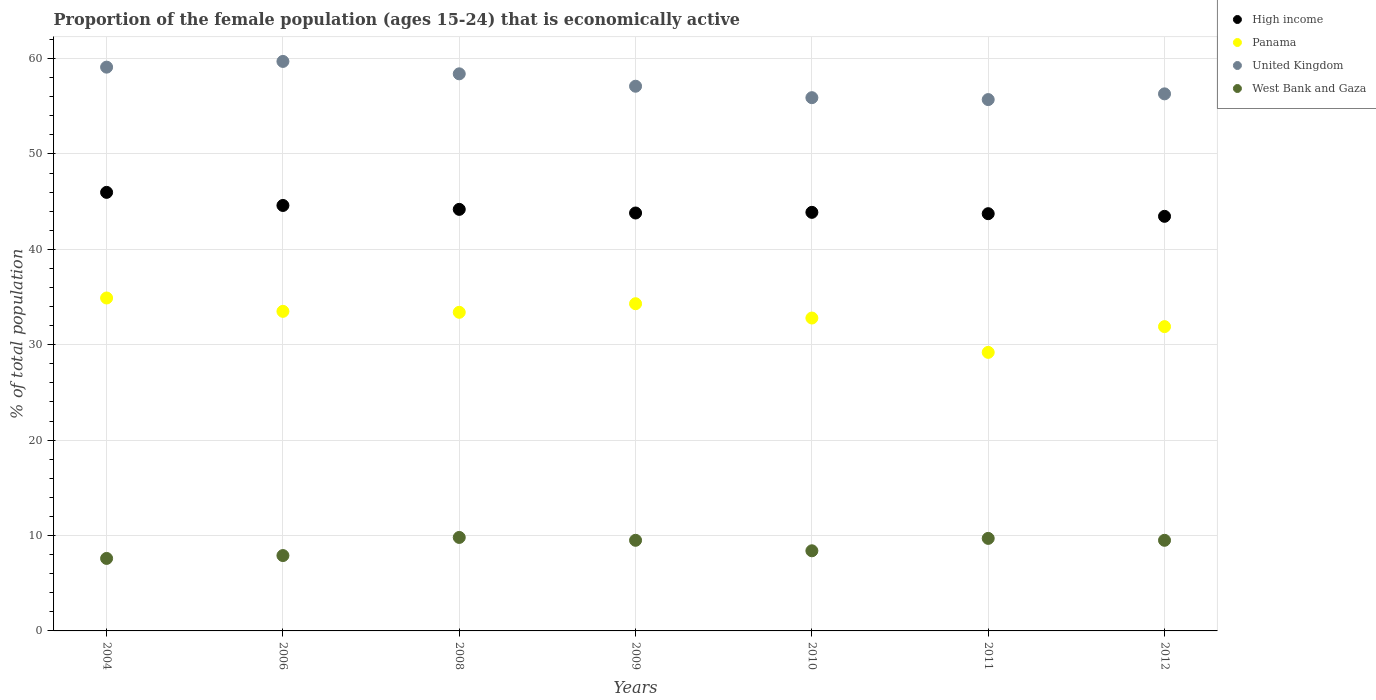Is the number of dotlines equal to the number of legend labels?
Your response must be concise. Yes. What is the proportion of the female population that is economically active in United Kingdom in 2006?
Provide a succinct answer. 59.7. Across all years, what is the maximum proportion of the female population that is economically active in West Bank and Gaza?
Your answer should be very brief. 9.8. Across all years, what is the minimum proportion of the female population that is economically active in Panama?
Make the answer very short. 29.2. In which year was the proportion of the female population that is economically active in Panama maximum?
Offer a very short reply. 2004. In which year was the proportion of the female population that is economically active in West Bank and Gaza minimum?
Make the answer very short. 2004. What is the total proportion of the female population that is economically active in High income in the graph?
Keep it short and to the point. 309.65. What is the difference between the proportion of the female population that is economically active in Panama in 2011 and that in 2012?
Your answer should be very brief. -2.7. What is the difference between the proportion of the female population that is economically active in United Kingdom in 2012 and the proportion of the female population that is economically active in West Bank and Gaza in 2008?
Offer a very short reply. 46.5. What is the average proportion of the female population that is economically active in Panama per year?
Your answer should be very brief. 32.86. In the year 2009, what is the difference between the proportion of the female population that is economically active in Panama and proportion of the female population that is economically active in United Kingdom?
Provide a short and direct response. -22.8. In how many years, is the proportion of the female population that is economically active in United Kingdom greater than 18 %?
Your response must be concise. 7. What is the ratio of the proportion of the female population that is economically active in High income in 2004 to that in 2009?
Provide a short and direct response. 1.05. Is the proportion of the female population that is economically active in West Bank and Gaza in 2006 less than that in 2009?
Provide a succinct answer. Yes. What is the difference between the highest and the second highest proportion of the female population that is economically active in West Bank and Gaza?
Ensure brevity in your answer.  0.1. What is the difference between the highest and the lowest proportion of the female population that is economically active in West Bank and Gaza?
Offer a very short reply. 2.2. In how many years, is the proportion of the female population that is economically active in West Bank and Gaza greater than the average proportion of the female population that is economically active in West Bank and Gaza taken over all years?
Your response must be concise. 4. Is the sum of the proportion of the female population that is economically active in West Bank and Gaza in 2011 and 2012 greater than the maximum proportion of the female population that is economically active in Panama across all years?
Offer a terse response. No. Is it the case that in every year, the sum of the proportion of the female population that is economically active in United Kingdom and proportion of the female population that is economically active in Panama  is greater than the sum of proportion of the female population that is economically active in High income and proportion of the female population that is economically active in West Bank and Gaza?
Provide a succinct answer. No. Is the proportion of the female population that is economically active in West Bank and Gaza strictly greater than the proportion of the female population that is economically active in Panama over the years?
Offer a terse response. No. Is the proportion of the female population that is economically active in High income strictly less than the proportion of the female population that is economically active in West Bank and Gaza over the years?
Make the answer very short. No. How many years are there in the graph?
Your answer should be very brief. 7. Are the values on the major ticks of Y-axis written in scientific E-notation?
Your answer should be very brief. No. Where does the legend appear in the graph?
Keep it short and to the point. Top right. What is the title of the graph?
Keep it short and to the point. Proportion of the female population (ages 15-24) that is economically active. Does "Barbados" appear as one of the legend labels in the graph?
Offer a very short reply. No. What is the label or title of the Y-axis?
Offer a terse response. % of total population. What is the % of total population of High income in 2004?
Give a very brief answer. 45.97. What is the % of total population of Panama in 2004?
Give a very brief answer. 34.9. What is the % of total population in United Kingdom in 2004?
Your answer should be compact. 59.1. What is the % of total population in West Bank and Gaza in 2004?
Your answer should be compact. 7.6. What is the % of total population of High income in 2006?
Offer a very short reply. 44.6. What is the % of total population of Panama in 2006?
Give a very brief answer. 33.5. What is the % of total population in United Kingdom in 2006?
Your answer should be very brief. 59.7. What is the % of total population of West Bank and Gaza in 2006?
Provide a succinct answer. 7.9. What is the % of total population in High income in 2008?
Your response must be concise. 44.19. What is the % of total population of Panama in 2008?
Provide a short and direct response. 33.4. What is the % of total population in United Kingdom in 2008?
Give a very brief answer. 58.4. What is the % of total population of West Bank and Gaza in 2008?
Offer a very short reply. 9.8. What is the % of total population of High income in 2009?
Your answer should be compact. 43.81. What is the % of total population in Panama in 2009?
Ensure brevity in your answer.  34.3. What is the % of total population in United Kingdom in 2009?
Ensure brevity in your answer.  57.1. What is the % of total population of West Bank and Gaza in 2009?
Offer a terse response. 9.5. What is the % of total population of High income in 2010?
Offer a terse response. 43.88. What is the % of total population in Panama in 2010?
Offer a very short reply. 32.8. What is the % of total population of United Kingdom in 2010?
Provide a succinct answer. 55.9. What is the % of total population of West Bank and Gaza in 2010?
Offer a terse response. 8.4. What is the % of total population of High income in 2011?
Your answer should be compact. 43.74. What is the % of total population in Panama in 2011?
Make the answer very short. 29.2. What is the % of total population of United Kingdom in 2011?
Your answer should be compact. 55.7. What is the % of total population in West Bank and Gaza in 2011?
Give a very brief answer. 9.7. What is the % of total population in High income in 2012?
Ensure brevity in your answer.  43.46. What is the % of total population of Panama in 2012?
Give a very brief answer. 31.9. What is the % of total population in United Kingdom in 2012?
Your answer should be very brief. 56.3. Across all years, what is the maximum % of total population of High income?
Your answer should be compact. 45.97. Across all years, what is the maximum % of total population in Panama?
Give a very brief answer. 34.9. Across all years, what is the maximum % of total population of United Kingdom?
Provide a succinct answer. 59.7. Across all years, what is the maximum % of total population of West Bank and Gaza?
Offer a terse response. 9.8. Across all years, what is the minimum % of total population of High income?
Ensure brevity in your answer.  43.46. Across all years, what is the minimum % of total population of Panama?
Your response must be concise. 29.2. Across all years, what is the minimum % of total population of United Kingdom?
Provide a short and direct response. 55.7. Across all years, what is the minimum % of total population of West Bank and Gaza?
Give a very brief answer. 7.6. What is the total % of total population of High income in the graph?
Ensure brevity in your answer.  309.65. What is the total % of total population in Panama in the graph?
Provide a short and direct response. 230. What is the total % of total population of United Kingdom in the graph?
Provide a succinct answer. 402.2. What is the total % of total population of West Bank and Gaza in the graph?
Keep it short and to the point. 62.4. What is the difference between the % of total population in High income in 2004 and that in 2006?
Your answer should be compact. 1.37. What is the difference between the % of total population in West Bank and Gaza in 2004 and that in 2006?
Give a very brief answer. -0.3. What is the difference between the % of total population of High income in 2004 and that in 2008?
Keep it short and to the point. 1.78. What is the difference between the % of total population in United Kingdom in 2004 and that in 2008?
Give a very brief answer. 0.7. What is the difference between the % of total population of High income in 2004 and that in 2009?
Offer a very short reply. 2.16. What is the difference between the % of total population of United Kingdom in 2004 and that in 2009?
Ensure brevity in your answer.  2. What is the difference between the % of total population of High income in 2004 and that in 2010?
Provide a short and direct response. 2.09. What is the difference between the % of total population in United Kingdom in 2004 and that in 2010?
Ensure brevity in your answer.  3.2. What is the difference between the % of total population of High income in 2004 and that in 2011?
Provide a succinct answer. 2.23. What is the difference between the % of total population of Panama in 2004 and that in 2011?
Your answer should be compact. 5.7. What is the difference between the % of total population in West Bank and Gaza in 2004 and that in 2011?
Provide a succinct answer. -2.1. What is the difference between the % of total population in High income in 2004 and that in 2012?
Your response must be concise. 2.51. What is the difference between the % of total population in United Kingdom in 2004 and that in 2012?
Make the answer very short. 2.8. What is the difference between the % of total population in High income in 2006 and that in 2008?
Give a very brief answer. 0.41. What is the difference between the % of total population in United Kingdom in 2006 and that in 2008?
Provide a succinct answer. 1.3. What is the difference between the % of total population of West Bank and Gaza in 2006 and that in 2008?
Provide a short and direct response. -1.9. What is the difference between the % of total population of High income in 2006 and that in 2009?
Ensure brevity in your answer.  0.79. What is the difference between the % of total population of Panama in 2006 and that in 2009?
Keep it short and to the point. -0.8. What is the difference between the % of total population of High income in 2006 and that in 2010?
Provide a succinct answer. 0.72. What is the difference between the % of total population of Panama in 2006 and that in 2010?
Offer a very short reply. 0.7. What is the difference between the % of total population of United Kingdom in 2006 and that in 2010?
Your answer should be compact. 3.8. What is the difference between the % of total population of High income in 2006 and that in 2011?
Keep it short and to the point. 0.86. What is the difference between the % of total population of Panama in 2006 and that in 2011?
Your answer should be compact. 4.3. What is the difference between the % of total population in United Kingdom in 2006 and that in 2011?
Your response must be concise. 4. What is the difference between the % of total population in West Bank and Gaza in 2006 and that in 2011?
Give a very brief answer. -1.8. What is the difference between the % of total population of High income in 2006 and that in 2012?
Offer a terse response. 1.14. What is the difference between the % of total population of High income in 2008 and that in 2009?
Your answer should be compact. 0.38. What is the difference between the % of total population in Panama in 2008 and that in 2009?
Provide a short and direct response. -0.9. What is the difference between the % of total population in United Kingdom in 2008 and that in 2009?
Your answer should be compact. 1.3. What is the difference between the % of total population of High income in 2008 and that in 2010?
Provide a succinct answer. 0.31. What is the difference between the % of total population in High income in 2008 and that in 2011?
Provide a succinct answer. 0.45. What is the difference between the % of total population of West Bank and Gaza in 2008 and that in 2011?
Give a very brief answer. 0.1. What is the difference between the % of total population in High income in 2008 and that in 2012?
Make the answer very short. 0.73. What is the difference between the % of total population of Panama in 2008 and that in 2012?
Provide a short and direct response. 1.5. What is the difference between the % of total population in West Bank and Gaza in 2008 and that in 2012?
Keep it short and to the point. 0.3. What is the difference between the % of total population of High income in 2009 and that in 2010?
Keep it short and to the point. -0.07. What is the difference between the % of total population in Panama in 2009 and that in 2010?
Your answer should be very brief. 1.5. What is the difference between the % of total population of High income in 2009 and that in 2011?
Provide a succinct answer. 0.07. What is the difference between the % of total population in West Bank and Gaza in 2009 and that in 2011?
Your answer should be compact. -0.2. What is the difference between the % of total population of High income in 2009 and that in 2012?
Give a very brief answer. 0.35. What is the difference between the % of total population of United Kingdom in 2009 and that in 2012?
Make the answer very short. 0.8. What is the difference between the % of total population of High income in 2010 and that in 2011?
Provide a short and direct response. 0.14. What is the difference between the % of total population of West Bank and Gaza in 2010 and that in 2011?
Offer a very short reply. -1.3. What is the difference between the % of total population of High income in 2010 and that in 2012?
Offer a very short reply. 0.42. What is the difference between the % of total population in West Bank and Gaza in 2010 and that in 2012?
Make the answer very short. -1.1. What is the difference between the % of total population in High income in 2011 and that in 2012?
Provide a short and direct response. 0.28. What is the difference between the % of total population in High income in 2004 and the % of total population in Panama in 2006?
Provide a succinct answer. 12.47. What is the difference between the % of total population in High income in 2004 and the % of total population in United Kingdom in 2006?
Give a very brief answer. -13.73. What is the difference between the % of total population of High income in 2004 and the % of total population of West Bank and Gaza in 2006?
Offer a very short reply. 38.07. What is the difference between the % of total population in Panama in 2004 and the % of total population in United Kingdom in 2006?
Make the answer very short. -24.8. What is the difference between the % of total population of Panama in 2004 and the % of total population of West Bank and Gaza in 2006?
Your answer should be compact. 27. What is the difference between the % of total population in United Kingdom in 2004 and the % of total population in West Bank and Gaza in 2006?
Give a very brief answer. 51.2. What is the difference between the % of total population in High income in 2004 and the % of total population in Panama in 2008?
Provide a succinct answer. 12.57. What is the difference between the % of total population of High income in 2004 and the % of total population of United Kingdom in 2008?
Give a very brief answer. -12.43. What is the difference between the % of total population of High income in 2004 and the % of total population of West Bank and Gaza in 2008?
Ensure brevity in your answer.  36.17. What is the difference between the % of total population of Panama in 2004 and the % of total population of United Kingdom in 2008?
Offer a terse response. -23.5. What is the difference between the % of total population in Panama in 2004 and the % of total population in West Bank and Gaza in 2008?
Your response must be concise. 25.1. What is the difference between the % of total population in United Kingdom in 2004 and the % of total population in West Bank and Gaza in 2008?
Offer a terse response. 49.3. What is the difference between the % of total population in High income in 2004 and the % of total population in Panama in 2009?
Your answer should be compact. 11.67. What is the difference between the % of total population of High income in 2004 and the % of total population of United Kingdom in 2009?
Offer a very short reply. -11.13. What is the difference between the % of total population in High income in 2004 and the % of total population in West Bank and Gaza in 2009?
Offer a very short reply. 36.47. What is the difference between the % of total population in Panama in 2004 and the % of total population in United Kingdom in 2009?
Keep it short and to the point. -22.2. What is the difference between the % of total population in Panama in 2004 and the % of total population in West Bank and Gaza in 2009?
Keep it short and to the point. 25.4. What is the difference between the % of total population in United Kingdom in 2004 and the % of total population in West Bank and Gaza in 2009?
Provide a short and direct response. 49.6. What is the difference between the % of total population of High income in 2004 and the % of total population of Panama in 2010?
Your answer should be compact. 13.17. What is the difference between the % of total population in High income in 2004 and the % of total population in United Kingdom in 2010?
Offer a very short reply. -9.93. What is the difference between the % of total population in High income in 2004 and the % of total population in West Bank and Gaza in 2010?
Offer a terse response. 37.57. What is the difference between the % of total population of United Kingdom in 2004 and the % of total population of West Bank and Gaza in 2010?
Provide a short and direct response. 50.7. What is the difference between the % of total population of High income in 2004 and the % of total population of Panama in 2011?
Your answer should be compact. 16.77. What is the difference between the % of total population of High income in 2004 and the % of total population of United Kingdom in 2011?
Offer a very short reply. -9.73. What is the difference between the % of total population in High income in 2004 and the % of total population in West Bank and Gaza in 2011?
Give a very brief answer. 36.27. What is the difference between the % of total population of Panama in 2004 and the % of total population of United Kingdom in 2011?
Provide a short and direct response. -20.8. What is the difference between the % of total population of Panama in 2004 and the % of total population of West Bank and Gaza in 2011?
Offer a terse response. 25.2. What is the difference between the % of total population in United Kingdom in 2004 and the % of total population in West Bank and Gaza in 2011?
Make the answer very short. 49.4. What is the difference between the % of total population in High income in 2004 and the % of total population in Panama in 2012?
Offer a terse response. 14.07. What is the difference between the % of total population in High income in 2004 and the % of total population in United Kingdom in 2012?
Ensure brevity in your answer.  -10.33. What is the difference between the % of total population in High income in 2004 and the % of total population in West Bank and Gaza in 2012?
Make the answer very short. 36.47. What is the difference between the % of total population in Panama in 2004 and the % of total population in United Kingdom in 2012?
Give a very brief answer. -21.4. What is the difference between the % of total population of Panama in 2004 and the % of total population of West Bank and Gaza in 2012?
Your response must be concise. 25.4. What is the difference between the % of total population of United Kingdom in 2004 and the % of total population of West Bank and Gaza in 2012?
Give a very brief answer. 49.6. What is the difference between the % of total population of High income in 2006 and the % of total population of Panama in 2008?
Your response must be concise. 11.2. What is the difference between the % of total population of High income in 2006 and the % of total population of United Kingdom in 2008?
Keep it short and to the point. -13.8. What is the difference between the % of total population of High income in 2006 and the % of total population of West Bank and Gaza in 2008?
Provide a succinct answer. 34.8. What is the difference between the % of total population of Panama in 2006 and the % of total population of United Kingdom in 2008?
Make the answer very short. -24.9. What is the difference between the % of total population in Panama in 2006 and the % of total population in West Bank and Gaza in 2008?
Provide a short and direct response. 23.7. What is the difference between the % of total population of United Kingdom in 2006 and the % of total population of West Bank and Gaza in 2008?
Keep it short and to the point. 49.9. What is the difference between the % of total population of High income in 2006 and the % of total population of Panama in 2009?
Provide a succinct answer. 10.3. What is the difference between the % of total population in High income in 2006 and the % of total population in United Kingdom in 2009?
Your response must be concise. -12.5. What is the difference between the % of total population of High income in 2006 and the % of total population of West Bank and Gaza in 2009?
Offer a terse response. 35.1. What is the difference between the % of total population of Panama in 2006 and the % of total population of United Kingdom in 2009?
Your answer should be very brief. -23.6. What is the difference between the % of total population in Panama in 2006 and the % of total population in West Bank and Gaza in 2009?
Offer a terse response. 24. What is the difference between the % of total population in United Kingdom in 2006 and the % of total population in West Bank and Gaza in 2009?
Make the answer very short. 50.2. What is the difference between the % of total population in High income in 2006 and the % of total population in Panama in 2010?
Offer a very short reply. 11.8. What is the difference between the % of total population in High income in 2006 and the % of total population in United Kingdom in 2010?
Ensure brevity in your answer.  -11.3. What is the difference between the % of total population of High income in 2006 and the % of total population of West Bank and Gaza in 2010?
Keep it short and to the point. 36.2. What is the difference between the % of total population in Panama in 2006 and the % of total population in United Kingdom in 2010?
Provide a succinct answer. -22.4. What is the difference between the % of total population in Panama in 2006 and the % of total population in West Bank and Gaza in 2010?
Provide a succinct answer. 25.1. What is the difference between the % of total population of United Kingdom in 2006 and the % of total population of West Bank and Gaza in 2010?
Make the answer very short. 51.3. What is the difference between the % of total population in High income in 2006 and the % of total population in Panama in 2011?
Provide a short and direct response. 15.4. What is the difference between the % of total population of High income in 2006 and the % of total population of United Kingdom in 2011?
Provide a short and direct response. -11.1. What is the difference between the % of total population of High income in 2006 and the % of total population of West Bank and Gaza in 2011?
Keep it short and to the point. 34.9. What is the difference between the % of total population in Panama in 2006 and the % of total population in United Kingdom in 2011?
Provide a short and direct response. -22.2. What is the difference between the % of total population in Panama in 2006 and the % of total population in West Bank and Gaza in 2011?
Ensure brevity in your answer.  23.8. What is the difference between the % of total population of United Kingdom in 2006 and the % of total population of West Bank and Gaza in 2011?
Your answer should be compact. 50. What is the difference between the % of total population in High income in 2006 and the % of total population in Panama in 2012?
Offer a very short reply. 12.7. What is the difference between the % of total population in High income in 2006 and the % of total population in United Kingdom in 2012?
Your answer should be compact. -11.7. What is the difference between the % of total population in High income in 2006 and the % of total population in West Bank and Gaza in 2012?
Ensure brevity in your answer.  35.1. What is the difference between the % of total population of Panama in 2006 and the % of total population of United Kingdom in 2012?
Offer a terse response. -22.8. What is the difference between the % of total population of United Kingdom in 2006 and the % of total population of West Bank and Gaza in 2012?
Give a very brief answer. 50.2. What is the difference between the % of total population in High income in 2008 and the % of total population in Panama in 2009?
Your answer should be compact. 9.89. What is the difference between the % of total population of High income in 2008 and the % of total population of United Kingdom in 2009?
Your response must be concise. -12.91. What is the difference between the % of total population in High income in 2008 and the % of total population in West Bank and Gaza in 2009?
Your answer should be very brief. 34.69. What is the difference between the % of total population of Panama in 2008 and the % of total population of United Kingdom in 2009?
Provide a short and direct response. -23.7. What is the difference between the % of total population of Panama in 2008 and the % of total population of West Bank and Gaza in 2009?
Make the answer very short. 23.9. What is the difference between the % of total population in United Kingdom in 2008 and the % of total population in West Bank and Gaza in 2009?
Provide a succinct answer. 48.9. What is the difference between the % of total population of High income in 2008 and the % of total population of Panama in 2010?
Give a very brief answer. 11.39. What is the difference between the % of total population of High income in 2008 and the % of total population of United Kingdom in 2010?
Offer a terse response. -11.71. What is the difference between the % of total population in High income in 2008 and the % of total population in West Bank and Gaza in 2010?
Offer a terse response. 35.79. What is the difference between the % of total population of Panama in 2008 and the % of total population of United Kingdom in 2010?
Offer a very short reply. -22.5. What is the difference between the % of total population of High income in 2008 and the % of total population of Panama in 2011?
Your answer should be very brief. 14.99. What is the difference between the % of total population of High income in 2008 and the % of total population of United Kingdom in 2011?
Offer a very short reply. -11.51. What is the difference between the % of total population in High income in 2008 and the % of total population in West Bank and Gaza in 2011?
Your answer should be compact. 34.49. What is the difference between the % of total population in Panama in 2008 and the % of total population in United Kingdom in 2011?
Your answer should be very brief. -22.3. What is the difference between the % of total population in Panama in 2008 and the % of total population in West Bank and Gaza in 2011?
Give a very brief answer. 23.7. What is the difference between the % of total population of United Kingdom in 2008 and the % of total population of West Bank and Gaza in 2011?
Provide a short and direct response. 48.7. What is the difference between the % of total population of High income in 2008 and the % of total population of Panama in 2012?
Offer a terse response. 12.29. What is the difference between the % of total population of High income in 2008 and the % of total population of United Kingdom in 2012?
Your answer should be compact. -12.11. What is the difference between the % of total population in High income in 2008 and the % of total population in West Bank and Gaza in 2012?
Your response must be concise. 34.69. What is the difference between the % of total population of Panama in 2008 and the % of total population of United Kingdom in 2012?
Ensure brevity in your answer.  -22.9. What is the difference between the % of total population in Panama in 2008 and the % of total population in West Bank and Gaza in 2012?
Your answer should be compact. 23.9. What is the difference between the % of total population of United Kingdom in 2008 and the % of total population of West Bank and Gaza in 2012?
Give a very brief answer. 48.9. What is the difference between the % of total population in High income in 2009 and the % of total population in Panama in 2010?
Offer a very short reply. 11.01. What is the difference between the % of total population in High income in 2009 and the % of total population in United Kingdom in 2010?
Offer a very short reply. -12.09. What is the difference between the % of total population in High income in 2009 and the % of total population in West Bank and Gaza in 2010?
Your response must be concise. 35.41. What is the difference between the % of total population in Panama in 2009 and the % of total population in United Kingdom in 2010?
Your response must be concise. -21.6. What is the difference between the % of total population of Panama in 2009 and the % of total population of West Bank and Gaza in 2010?
Offer a very short reply. 25.9. What is the difference between the % of total population in United Kingdom in 2009 and the % of total population in West Bank and Gaza in 2010?
Keep it short and to the point. 48.7. What is the difference between the % of total population in High income in 2009 and the % of total population in Panama in 2011?
Give a very brief answer. 14.61. What is the difference between the % of total population of High income in 2009 and the % of total population of United Kingdom in 2011?
Make the answer very short. -11.89. What is the difference between the % of total population of High income in 2009 and the % of total population of West Bank and Gaza in 2011?
Provide a short and direct response. 34.11. What is the difference between the % of total population of Panama in 2009 and the % of total population of United Kingdom in 2011?
Make the answer very short. -21.4. What is the difference between the % of total population of Panama in 2009 and the % of total population of West Bank and Gaza in 2011?
Ensure brevity in your answer.  24.6. What is the difference between the % of total population in United Kingdom in 2009 and the % of total population in West Bank and Gaza in 2011?
Provide a short and direct response. 47.4. What is the difference between the % of total population of High income in 2009 and the % of total population of Panama in 2012?
Provide a succinct answer. 11.91. What is the difference between the % of total population in High income in 2009 and the % of total population in United Kingdom in 2012?
Your answer should be very brief. -12.49. What is the difference between the % of total population of High income in 2009 and the % of total population of West Bank and Gaza in 2012?
Offer a terse response. 34.31. What is the difference between the % of total population of Panama in 2009 and the % of total population of West Bank and Gaza in 2012?
Ensure brevity in your answer.  24.8. What is the difference between the % of total population in United Kingdom in 2009 and the % of total population in West Bank and Gaza in 2012?
Your answer should be very brief. 47.6. What is the difference between the % of total population of High income in 2010 and the % of total population of Panama in 2011?
Your answer should be compact. 14.68. What is the difference between the % of total population of High income in 2010 and the % of total population of United Kingdom in 2011?
Provide a succinct answer. -11.82. What is the difference between the % of total population in High income in 2010 and the % of total population in West Bank and Gaza in 2011?
Your answer should be compact. 34.18. What is the difference between the % of total population in Panama in 2010 and the % of total population in United Kingdom in 2011?
Provide a short and direct response. -22.9. What is the difference between the % of total population of Panama in 2010 and the % of total population of West Bank and Gaza in 2011?
Offer a very short reply. 23.1. What is the difference between the % of total population of United Kingdom in 2010 and the % of total population of West Bank and Gaza in 2011?
Provide a succinct answer. 46.2. What is the difference between the % of total population of High income in 2010 and the % of total population of Panama in 2012?
Offer a terse response. 11.98. What is the difference between the % of total population of High income in 2010 and the % of total population of United Kingdom in 2012?
Offer a terse response. -12.42. What is the difference between the % of total population of High income in 2010 and the % of total population of West Bank and Gaza in 2012?
Provide a short and direct response. 34.38. What is the difference between the % of total population of Panama in 2010 and the % of total population of United Kingdom in 2012?
Make the answer very short. -23.5. What is the difference between the % of total population in Panama in 2010 and the % of total population in West Bank and Gaza in 2012?
Offer a terse response. 23.3. What is the difference between the % of total population of United Kingdom in 2010 and the % of total population of West Bank and Gaza in 2012?
Your answer should be very brief. 46.4. What is the difference between the % of total population in High income in 2011 and the % of total population in Panama in 2012?
Your response must be concise. 11.84. What is the difference between the % of total population in High income in 2011 and the % of total population in United Kingdom in 2012?
Your answer should be compact. -12.56. What is the difference between the % of total population in High income in 2011 and the % of total population in West Bank and Gaza in 2012?
Offer a very short reply. 34.24. What is the difference between the % of total population in Panama in 2011 and the % of total population in United Kingdom in 2012?
Provide a short and direct response. -27.1. What is the difference between the % of total population of Panama in 2011 and the % of total population of West Bank and Gaza in 2012?
Provide a succinct answer. 19.7. What is the difference between the % of total population of United Kingdom in 2011 and the % of total population of West Bank and Gaza in 2012?
Make the answer very short. 46.2. What is the average % of total population in High income per year?
Your answer should be very brief. 44.24. What is the average % of total population of Panama per year?
Offer a terse response. 32.86. What is the average % of total population in United Kingdom per year?
Offer a very short reply. 57.46. What is the average % of total population in West Bank and Gaza per year?
Keep it short and to the point. 8.91. In the year 2004, what is the difference between the % of total population in High income and % of total population in Panama?
Give a very brief answer. 11.07. In the year 2004, what is the difference between the % of total population of High income and % of total population of United Kingdom?
Give a very brief answer. -13.13. In the year 2004, what is the difference between the % of total population in High income and % of total population in West Bank and Gaza?
Offer a very short reply. 38.37. In the year 2004, what is the difference between the % of total population in Panama and % of total population in United Kingdom?
Offer a terse response. -24.2. In the year 2004, what is the difference between the % of total population of Panama and % of total population of West Bank and Gaza?
Ensure brevity in your answer.  27.3. In the year 2004, what is the difference between the % of total population of United Kingdom and % of total population of West Bank and Gaza?
Your answer should be very brief. 51.5. In the year 2006, what is the difference between the % of total population of High income and % of total population of Panama?
Offer a very short reply. 11.1. In the year 2006, what is the difference between the % of total population of High income and % of total population of United Kingdom?
Give a very brief answer. -15.1. In the year 2006, what is the difference between the % of total population in High income and % of total population in West Bank and Gaza?
Provide a succinct answer. 36.7. In the year 2006, what is the difference between the % of total population of Panama and % of total population of United Kingdom?
Your response must be concise. -26.2. In the year 2006, what is the difference between the % of total population in Panama and % of total population in West Bank and Gaza?
Offer a very short reply. 25.6. In the year 2006, what is the difference between the % of total population of United Kingdom and % of total population of West Bank and Gaza?
Your response must be concise. 51.8. In the year 2008, what is the difference between the % of total population in High income and % of total population in Panama?
Your answer should be very brief. 10.79. In the year 2008, what is the difference between the % of total population of High income and % of total population of United Kingdom?
Your answer should be compact. -14.21. In the year 2008, what is the difference between the % of total population of High income and % of total population of West Bank and Gaza?
Your answer should be very brief. 34.39. In the year 2008, what is the difference between the % of total population of Panama and % of total population of United Kingdom?
Ensure brevity in your answer.  -25. In the year 2008, what is the difference between the % of total population in Panama and % of total population in West Bank and Gaza?
Make the answer very short. 23.6. In the year 2008, what is the difference between the % of total population in United Kingdom and % of total population in West Bank and Gaza?
Provide a succinct answer. 48.6. In the year 2009, what is the difference between the % of total population in High income and % of total population in Panama?
Your answer should be compact. 9.51. In the year 2009, what is the difference between the % of total population in High income and % of total population in United Kingdom?
Offer a very short reply. -13.29. In the year 2009, what is the difference between the % of total population in High income and % of total population in West Bank and Gaza?
Your answer should be very brief. 34.31. In the year 2009, what is the difference between the % of total population in Panama and % of total population in United Kingdom?
Provide a short and direct response. -22.8. In the year 2009, what is the difference between the % of total population of Panama and % of total population of West Bank and Gaza?
Provide a short and direct response. 24.8. In the year 2009, what is the difference between the % of total population of United Kingdom and % of total population of West Bank and Gaza?
Make the answer very short. 47.6. In the year 2010, what is the difference between the % of total population of High income and % of total population of Panama?
Provide a succinct answer. 11.08. In the year 2010, what is the difference between the % of total population in High income and % of total population in United Kingdom?
Provide a short and direct response. -12.02. In the year 2010, what is the difference between the % of total population in High income and % of total population in West Bank and Gaza?
Provide a succinct answer. 35.48. In the year 2010, what is the difference between the % of total population in Panama and % of total population in United Kingdom?
Offer a very short reply. -23.1. In the year 2010, what is the difference between the % of total population in Panama and % of total population in West Bank and Gaza?
Keep it short and to the point. 24.4. In the year 2010, what is the difference between the % of total population in United Kingdom and % of total population in West Bank and Gaza?
Provide a short and direct response. 47.5. In the year 2011, what is the difference between the % of total population in High income and % of total population in Panama?
Provide a succinct answer. 14.54. In the year 2011, what is the difference between the % of total population in High income and % of total population in United Kingdom?
Offer a terse response. -11.96. In the year 2011, what is the difference between the % of total population of High income and % of total population of West Bank and Gaza?
Provide a succinct answer. 34.04. In the year 2011, what is the difference between the % of total population of Panama and % of total population of United Kingdom?
Provide a short and direct response. -26.5. In the year 2011, what is the difference between the % of total population of United Kingdom and % of total population of West Bank and Gaza?
Provide a short and direct response. 46. In the year 2012, what is the difference between the % of total population in High income and % of total population in Panama?
Your answer should be compact. 11.56. In the year 2012, what is the difference between the % of total population of High income and % of total population of United Kingdom?
Ensure brevity in your answer.  -12.84. In the year 2012, what is the difference between the % of total population of High income and % of total population of West Bank and Gaza?
Your answer should be very brief. 33.96. In the year 2012, what is the difference between the % of total population of Panama and % of total population of United Kingdom?
Keep it short and to the point. -24.4. In the year 2012, what is the difference between the % of total population of Panama and % of total population of West Bank and Gaza?
Ensure brevity in your answer.  22.4. In the year 2012, what is the difference between the % of total population of United Kingdom and % of total population of West Bank and Gaza?
Keep it short and to the point. 46.8. What is the ratio of the % of total population of High income in 2004 to that in 2006?
Give a very brief answer. 1.03. What is the ratio of the % of total population of Panama in 2004 to that in 2006?
Your answer should be very brief. 1.04. What is the ratio of the % of total population in United Kingdom in 2004 to that in 2006?
Ensure brevity in your answer.  0.99. What is the ratio of the % of total population of West Bank and Gaza in 2004 to that in 2006?
Offer a terse response. 0.96. What is the ratio of the % of total population of High income in 2004 to that in 2008?
Give a very brief answer. 1.04. What is the ratio of the % of total population in Panama in 2004 to that in 2008?
Provide a succinct answer. 1.04. What is the ratio of the % of total population of West Bank and Gaza in 2004 to that in 2008?
Give a very brief answer. 0.78. What is the ratio of the % of total population in High income in 2004 to that in 2009?
Ensure brevity in your answer.  1.05. What is the ratio of the % of total population of Panama in 2004 to that in 2009?
Your answer should be very brief. 1.02. What is the ratio of the % of total population in United Kingdom in 2004 to that in 2009?
Offer a very short reply. 1.03. What is the ratio of the % of total population of High income in 2004 to that in 2010?
Make the answer very short. 1.05. What is the ratio of the % of total population in Panama in 2004 to that in 2010?
Make the answer very short. 1.06. What is the ratio of the % of total population in United Kingdom in 2004 to that in 2010?
Keep it short and to the point. 1.06. What is the ratio of the % of total population in West Bank and Gaza in 2004 to that in 2010?
Provide a succinct answer. 0.9. What is the ratio of the % of total population of High income in 2004 to that in 2011?
Ensure brevity in your answer.  1.05. What is the ratio of the % of total population in Panama in 2004 to that in 2011?
Your response must be concise. 1.2. What is the ratio of the % of total population in United Kingdom in 2004 to that in 2011?
Provide a short and direct response. 1.06. What is the ratio of the % of total population in West Bank and Gaza in 2004 to that in 2011?
Make the answer very short. 0.78. What is the ratio of the % of total population of High income in 2004 to that in 2012?
Offer a terse response. 1.06. What is the ratio of the % of total population in Panama in 2004 to that in 2012?
Make the answer very short. 1.09. What is the ratio of the % of total population in United Kingdom in 2004 to that in 2012?
Provide a succinct answer. 1.05. What is the ratio of the % of total population in West Bank and Gaza in 2004 to that in 2012?
Make the answer very short. 0.8. What is the ratio of the % of total population in High income in 2006 to that in 2008?
Ensure brevity in your answer.  1.01. What is the ratio of the % of total population in Panama in 2006 to that in 2008?
Offer a terse response. 1. What is the ratio of the % of total population of United Kingdom in 2006 to that in 2008?
Offer a very short reply. 1.02. What is the ratio of the % of total population of West Bank and Gaza in 2006 to that in 2008?
Provide a short and direct response. 0.81. What is the ratio of the % of total population of High income in 2006 to that in 2009?
Offer a terse response. 1.02. What is the ratio of the % of total population of Panama in 2006 to that in 2009?
Offer a very short reply. 0.98. What is the ratio of the % of total population of United Kingdom in 2006 to that in 2009?
Offer a very short reply. 1.05. What is the ratio of the % of total population of West Bank and Gaza in 2006 to that in 2009?
Keep it short and to the point. 0.83. What is the ratio of the % of total population of High income in 2006 to that in 2010?
Offer a terse response. 1.02. What is the ratio of the % of total population in Panama in 2006 to that in 2010?
Offer a terse response. 1.02. What is the ratio of the % of total population in United Kingdom in 2006 to that in 2010?
Your answer should be compact. 1.07. What is the ratio of the % of total population in West Bank and Gaza in 2006 to that in 2010?
Keep it short and to the point. 0.94. What is the ratio of the % of total population in High income in 2006 to that in 2011?
Make the answer very short. 1.02. What is the ratio of the % of total population of Panama in 2006 to that in 2011?
Keep it short and to the point. 1.15. What is the ratio of the % of total population in United Kingdom in 2006 to that in 2011?
Your response must be concise. 1.07. What is the ratio of the % of total population of West Bank and Gaza in 2006 to that in 2011?
Provide a succinct answer. 0.81. What is the ratio of the % of total population of High income in 2006 to that in 2012?
Provide a short and direct response. 1.03. What is the ratio of the % of total population in Panama in 2006 to that in 2012?
Give a very brief answer. 1.05. What is the ratio of the % of total population of United Kingdom in 2006 to that in 2012?
Make the answer very short. 1.06. What is the ratio of the % of total population in West Bank and Gaza in 2006 to that in 2012?
Ensure brevity in your answer.  0.83. What is the ratio of the % of total population of High income in 2008 to that in 2009?
Provide a short and direct response. 1.01. What is the ratio of the % of total population in Panama in 2008 to that in 2009?
Offer a very short reply. 0.97. What is the ratio of the % of total population of United Kingdom in 2008 to that in 2009?
Your answer should be compact. 1.02. What is the ratio of the % of total population of West Bank and Gaza in 2008 to that in 2009?
Your answer should be compact. 1.03. What is the ratio of the % of total population in High income in 2008 to that in 2010?
Provide a short and direct response. 1.01. What is the ratio of the % of total population in Panama in 2008 to that in 2010?
Offer a very short reply. 1.02. What is the ratio of the % of total population in United Kingdom in 2008 to that in 2010?
Make the answer very short. 1.04. What is the ratio of the % of total population of High income in 2008 to that in 2011?
Your answer should be compact. 1.01. What is the ratio of the % of total population in Panama in 2008 to that in 2011?
Offer a very short reply. 1.14. What is the ratio of the % of total population of United Kingdom in 2008 to that in 2011?
Make the answer very short. 1.05. What is the ratio of the % of total population in West Bank and Gaza in 2008 to that in 2011?
Your answer should be very brief. 1.01. What is the ratio of the % of total population in High income in 2008 to that in 2012?
Offer a terse response. 1.02. What is the ratio of the % of total population in Panama in 2008 to that in 2012?
Your response must be concise. 1.05. What is the ratio of the % of total population in United Kingdom in 2008 to that in 2012?
Provide a short and direct response. 1.04. What is the ratio of the % of total population of West Bank and Gaza in 2008 to that in 2012?
Provide a succinct answer. 1.03. What is the ratio of the % of total population of Panama in 2009 to that in 2010?
Offer a terse response. 1.05. What is the ratio of the % of total population in United Kingdom in 2009 to that in 2010?
Give a very brief answer. 1.02. What is the ratio of the % of total population in West Bank and Gaza in 2009 to that in 2010?
Your answer should be very brief. 1.13. What is the ratio of the % of total population in High income in 2009 to that in 2011?
Your answer should be very brief. 1. What is the ratio of the % of total population of Panama in 2009 to that in 2011?
Offer a terse response. 1.17. What is the ratio of the % of total population of United Kingdom in 2009 to that in 2011?
Provide a short and direct response. 1.03. What is the ratio of the % of total population in West Bank and Gaza in 2009 to that in 2011?
Keep it short and to the point. 0.98. What is the ratio of the % of total population of High income in 2009 to that in 2012?
Offer a very short reply. 1.01. What is the ratio of the % of total population of Panama in 2009 to that in 2012?
Give a very brief answer. 1.08. What is the ratio of the % of total population in United Kingdom in 2009 to that in 2012?
Your answer should be compact. 1.01. What is the ratio of the % of total population of Panama in 2010 to that in 2011?
Your answer should be very brief. 1.12. What is the ratio of the % of total population of United Kingdom in 2010 to that in 2011?
Offer a very short reply. 1. What is the ratio of the % of total population in West Bank and Gaza in 2010 to that in 2011?
Make the answer very short. 0.87. What is the ratio of the % of total population of High income in 2010 to that in 2012?
Give a very brief answer. 1.01. What is the ratio of the % of total population of Panama in 2010 to that in 2012?
Keep it short and to the point. 1.03. What is the ratio of the % of total population of United Kingdom in 2010 to that in 2012?
Offer a very short reply. 0.99. What is the ratio of the % of total population of West Bank and Gaza in 2010 to that in 2012?
Offer a terse response. 0.88. What is the ratio of the % of total population in High income in 2011 to that in 2012?
Give a very brief answer. 1.01. What is the ratio of the % of total population of Panama in 2011 to that in 2012?
Ensure brevity in your answer.  0.92. What is the ratio of the % of total population of United Kingdom in 2011 to that in 2012?
Ensure brevity in your answer.  0.99. What is the ratio of the % of total population of West Bank and Gaza in 2011 to that in 2012?
Keep it short and to the point. 1.02. What is the difference between the highest and the second highest % of total population in High income?
Give a very brief answer. 1.37. What is the difference between the highest and the second highest % of total population of Panama?
Keep it short and to the point. 0.6. What is the difference between the highest and the second highest % of total population of United Kingdom?
Make the answer very short. 0.6. What is the difference between the highest and the lowest % of total population in High income?
Keep it short and to the point. 2.51. What is the difference between the highest and the lowest % of total population of Panama?
Provide a succinct answer. 5.7. What is the difference between the highest and the lowest % of total population of West Bank and Gaza?
Keep it short and to the point. 2.2. 